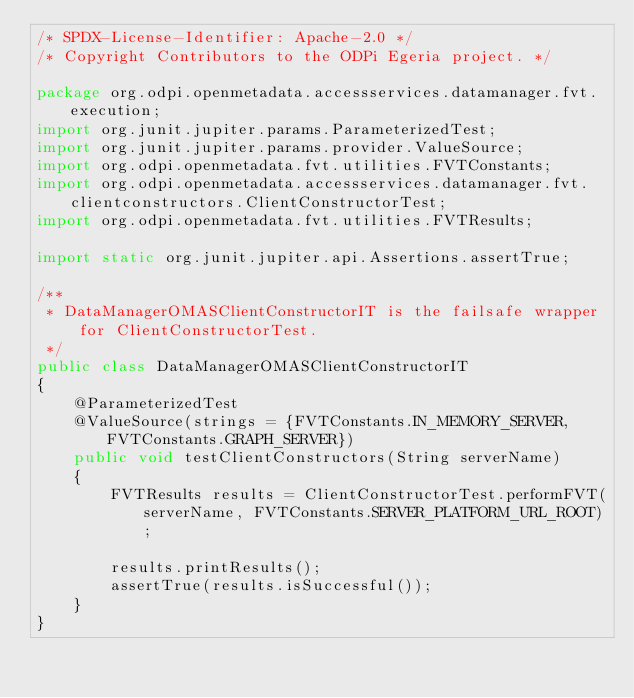Convert code to text. <code><loc_0><loc_0><loc_500><loc_500><_Java_>/* SPDX-License-Identifier: Apache-2.0 */
/* Copyright Contributors to the ODPi Egeria project. */

package org.odpi.openmetadata.accessservices.datamanager.fvt.execution;
import org.junit.jupiter.params.ParameterizedTest;
import org.junit.jupiter.params.provider.ValueSource;
import org.odpi.openmetadata.fvt.utilities.FVTConstants;
import org.odpi.openmetadata.accessservices.datamanager.fvt.clientconstructors.ClientConstructorTest;
import org.odpi.openmetadata.fvt.utilities.FVTResults;

import static org.junit.jupiter.api.Assertions.assertTrue;

/**
 * DataManagerOMASClientConstructorIT is the failsafe wrapper for ClientConstructorTest.
 */
public class DataManagerOMASClientConstructorIT
{
    @ParameterizedTest
    @ValueSource(strings = {FVTConstants.IN_MEMORY_SERVER, FVTConstants.GRAPH_SERVER})
    public void testClientConstructors(String serverName)
    {
        FVTResults results = ClientConstructorTest.performFVT(serverName, FVTConstants.SERVER_PLATFORM_URL_ROOT);

        results.printResults();
        assertTrue(results.isSuccessful());
    }
}
</code> 